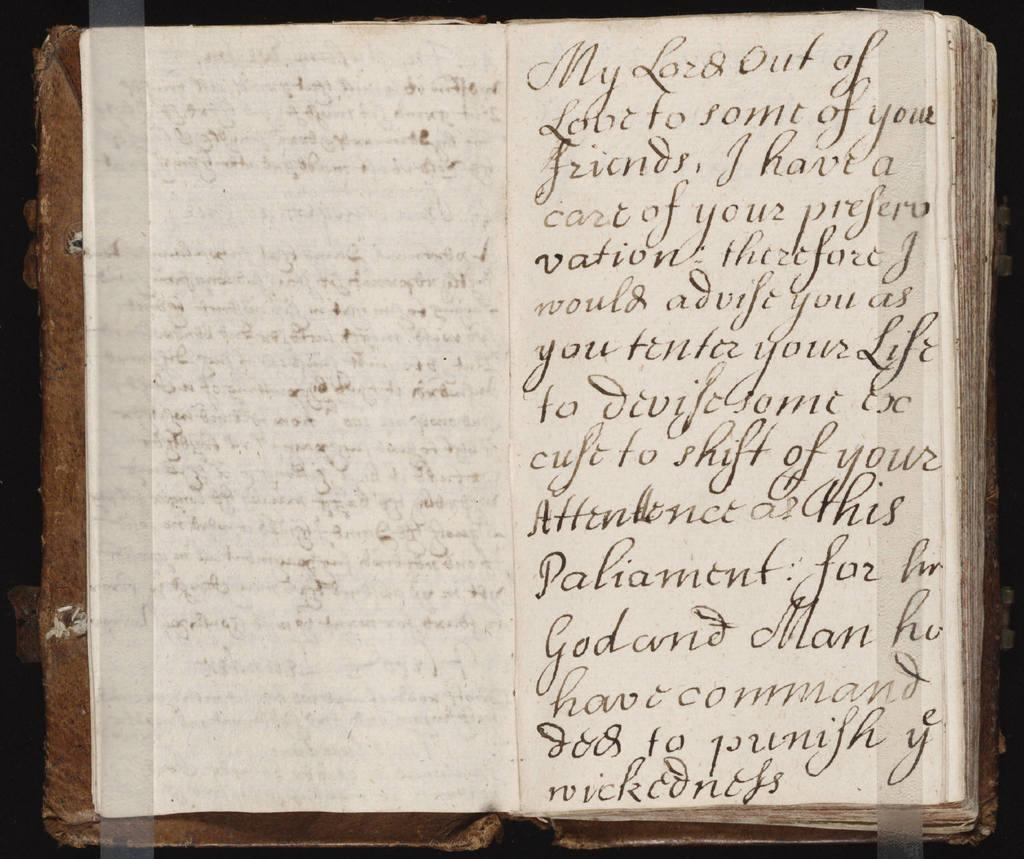<image>
Share a concise interpretation of the image provided. an open vintage book that is my lord out of love 